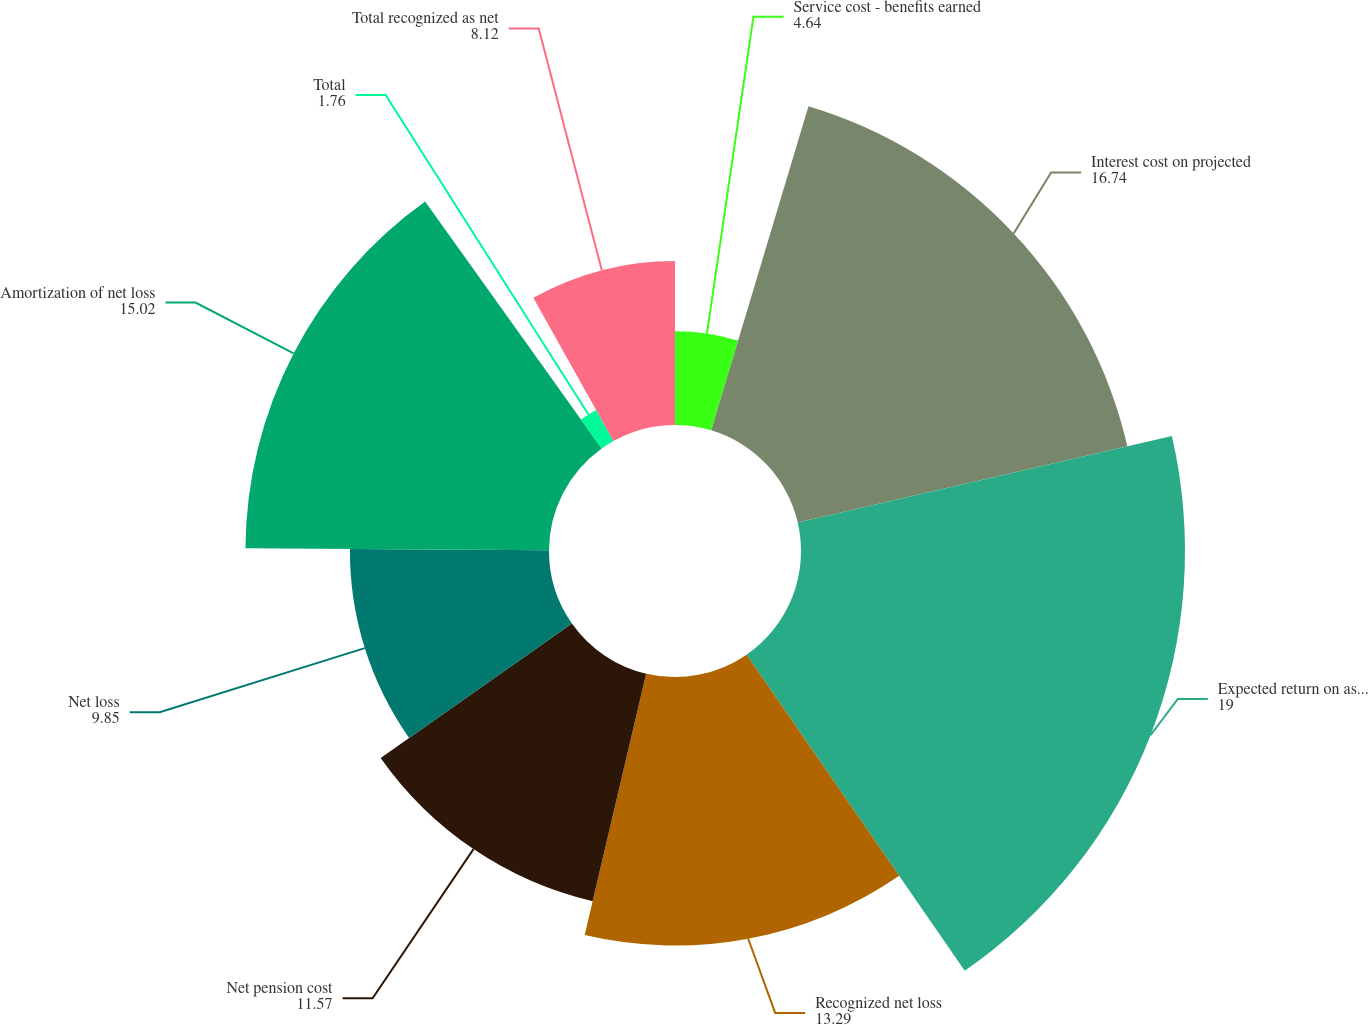Convert chart to OTSL. <chart><loc_0><loc_0><loc_500><loc_500><pie_chart><fcel>Service cost - benefits earned<fcel>Interest cost on projected<fcel>Expected return on assets<fcel>Recognized net loss<fcel>Net pension cost<fcel>Net loss<fcel>Amortization of net loss<fcel>Total<fcel>Total recognized as net<nl><fcel>4.64%<fcel>16.74%<fcel>19.0%<fcel>13.29%<fcel>11.57%<fcel>9.85%<fcel>15.02%<fcel>1.76%<fcel>8.12%<nl></chart> 